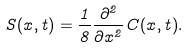<formula> <loc_0><loc_0><loc_500><loc_500>S ( x , t ) = \frac { 1 } { 8 } \frac { \partial ^ { 2 } } { \partial x ^ { 2 } } C ( x , t ) .</formula> 